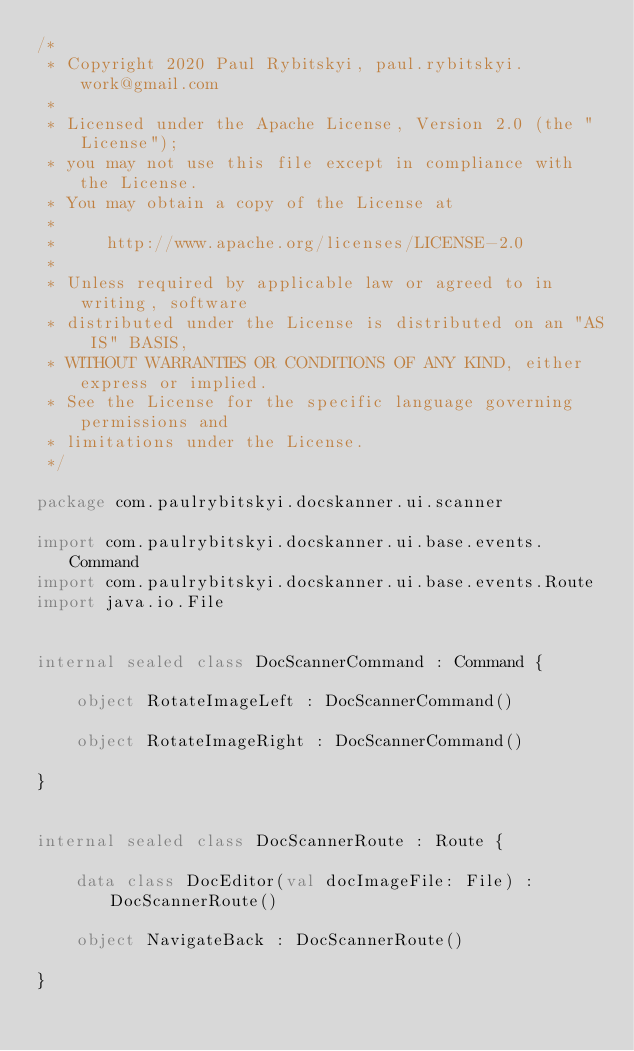Convert code to text. <code><loc_0><loc_0><loc_500><loc_500><_Kotlin_>/*
 * Copyright 2020 Paul Rybitskyi, paul.rybitskyi.work@gmail.com
 *
 * Licensed under the Apache License, Version 2.0 (the "License");
 * you may not use this file except in compliance with the License.
 * You may obtain a copy of the License at
 *
 *     http://www.apache.org/licenses/LICENSE-2.0
 *
 * Unless required by applicable law or agreed to in writing, software
 * distributed under the License is distributed on an "AS IS" BASIS,
 * WITHOUT WARRANTIES OR CONDITIONS OF ANY KIND, either express or implied.
 * See the License for the specific language governing permissions and
 * limitations under the License.
 */

package com.paulrybitskyi.docskanner.ui.scanner

import com.paulrybitskyi.docskanner.ui.base.events.Command
import com.paulrybitskyi.docskanner.ui.base.events.Route
import java.io.File


internal sealed class DocScannerCommand : Command {

    object RotateImageLeft : DocScannerCommand()

    object RotateImageRight : DocScannerCommand()

}


internal sealed class DocScannerRoute : Route {

    data class DocEditor(val docImageFile: File) : DocScannerRoute()

    object NavigateBack : DocScannerRoute()

}</code> 